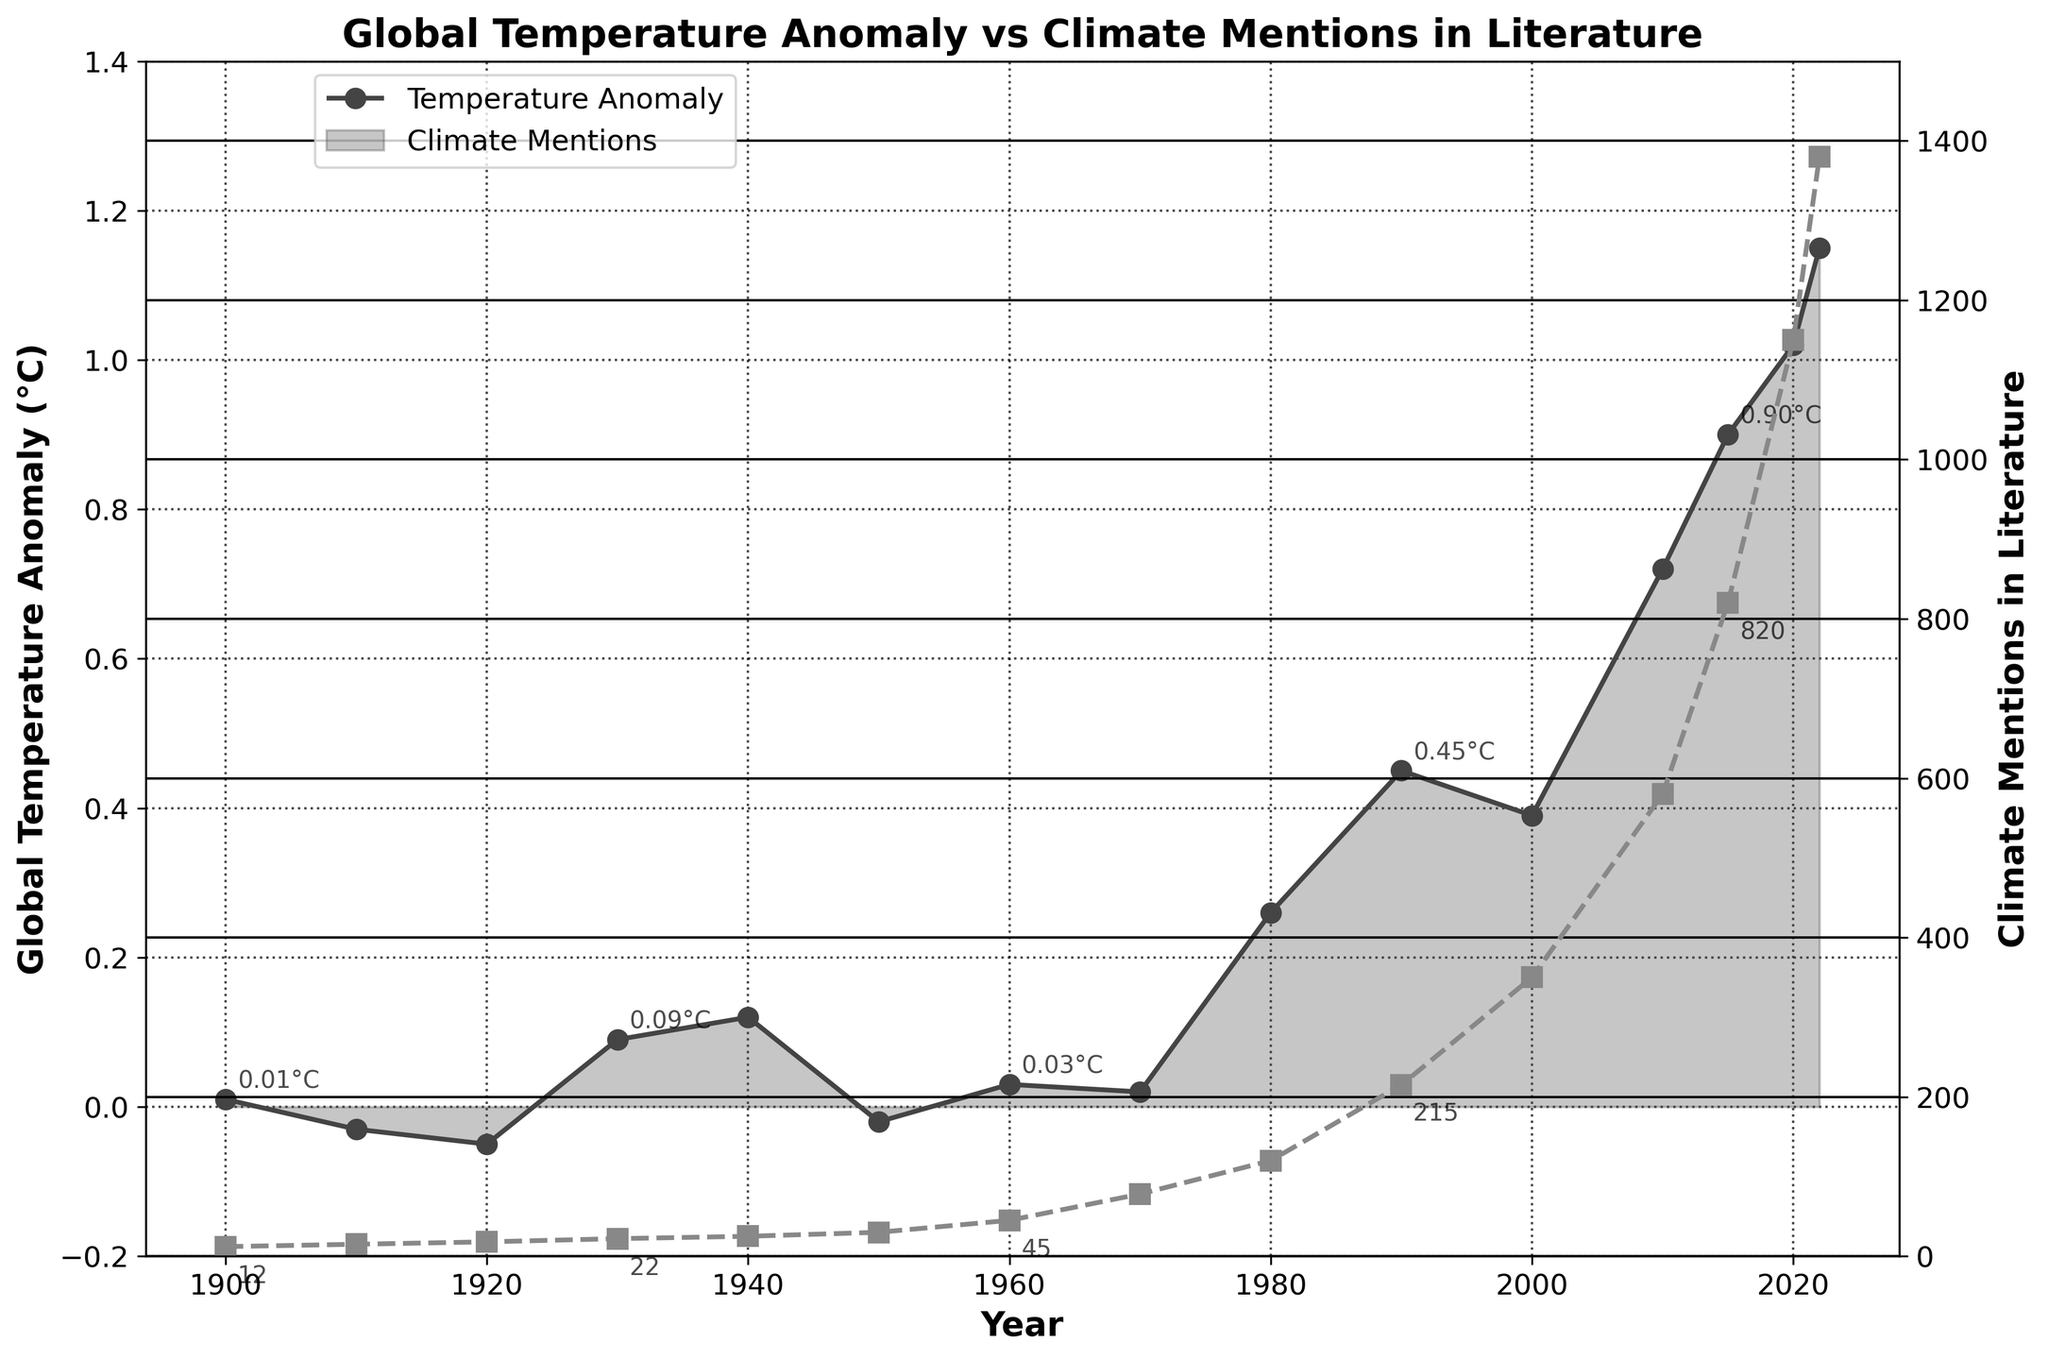What's the general trend of the global temperature anomaly from 1900 to 2022? By examining the plot, we see that the global temperature anomaly increases from around 0.01°C in 1900 to about 1.15°C in 2022. Overall, the trend shows a significant increase over this period.
Answer: Increasing What year had the highest global temperature anomaly, and what was the value? By observing the peaks in the plot, we notice that the highest temperature anomaly occurred in 2022, reaching approximately 1.15°C
Answer: 2022, 1.15°C How many times did the global temperature anomaly cross 0.0°C in the given period? The line chart shows the temperature anomaly crossing 0°C around the years 1910, 1920, 1950, and 1950-1960. This happens four times.
Answer: Four times Compare the number of climate mentions in literature between 1910 and 2020. Which year had more mentions and by what difference? In 1910, there were 15 mentions of climate, while in 2020, there were 1150 mentions. The difference is 1150 - 15 = 1135. Therefore, 2020 had 1135 more mentions than 1910.
Answer: 2020, 1135 more mentions What are the temperature anomalies and climate mentions in literature in 1990? From the chart, in 1990, the global temperature anomaly is around 0.45°C, and climate mentions in literature are approximately 215.
Answer: 0.45°C, 215 mentions Did the global temperature anomaly ever decrease after 2000, and if so, in which years? Examining the plot, the global temperature anomaly decreases only once after 2000, from 0.45°C in 2000 to 0.39°C in 2010.
Answer: Yes, in 2010 What is the average climate mentions from 1950 to 1980? The values for climate mentions from 1950 to 1980 are: 30, 45, 78, and 120. The sum is 30 + 45 + 78 + 120 = 273. The number of data points is 4, so the average is 273 / 4 = 68.25.
Answer: 68.25 Highlight the visual difference in the trends of temperature anomalies and climate mentions in literature after 1980. After 1980, both the global temperature anomaly and climate mentions show an increasing trend. However, the increase in climate mentions is much steeper compared to the increase in temperature anomaly, illustrating a growing awareness or concern in literature about climate issues.
Answer: Steeper increase in climate mentions How does the temperature anomaly in 1930 compare with that in 2020? In 1930, the temperature anomaly is around 0.09°C, while in 2020, it is around 1.02°C. The anomaly in 2020 is significantly higher, specifically about 1.02 - 0.09 = 0.93°C more than in 1930.
Answer: 2020 is 0.93°C higher Identify the year with the lowest global temperature anomaly and state its value? By looking at the lowest points in the plot, we find that the lowest temperature anomaly occurred in 1920, with a value of approximately -0.05°C.
Answer: 1920, -0.05°C 